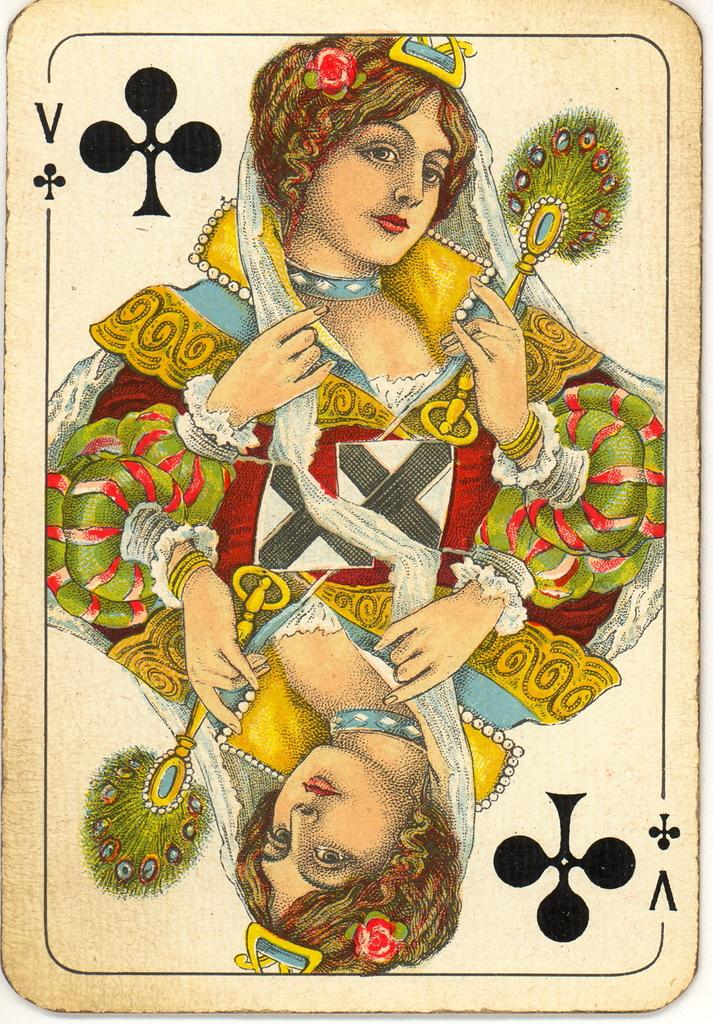What is at the top of the image? There is a queen at the top of the image. What is at the bottom of the image? There is a queen at the bottom of the image. What can be inferred about the queens in the image? Both queens are on a card. What type of condition is the coach in the image? There is no coach present in the image. How does the queen at the top of the image pull the queen at the bottom of the image? The queens do not move or interact in the image; they are stationary on a card. 